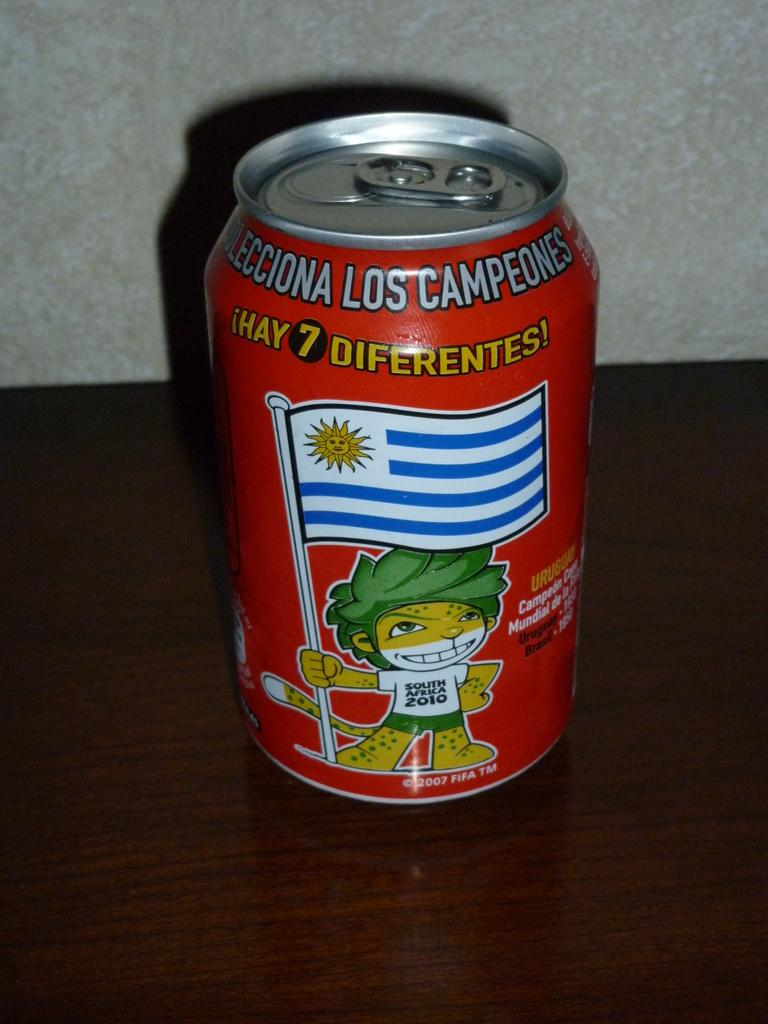What object is present on the wooden surface in the image? There is a drink can on the wooden surface in the image. What can be found on the surface of the drink can? The drink can has pictures and text on it. What is visible behind the drink can in the image? There is a wall visible behind the drink can. Can you tell me how many pies are being served on the wooden surface in the image? There are no pies present in the image; it only features a drink can on a wooden surface. What type of conversation is happening between the mice in the image? There are no mice present in the image, so it is not possible to determine any conversation between them. 